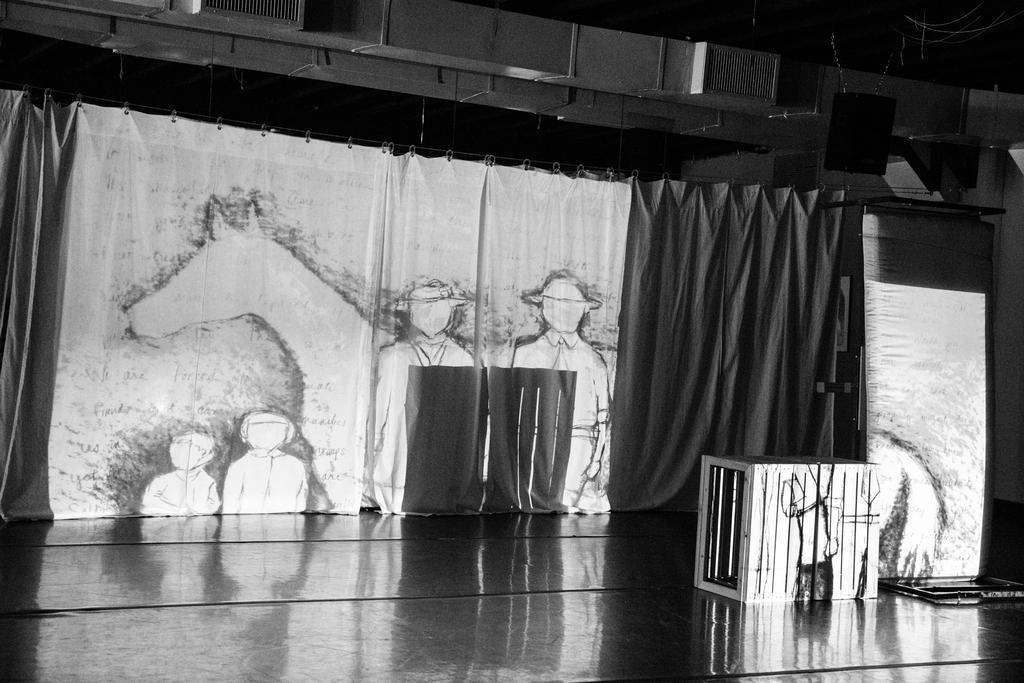Could you give a brief overview of what you see in this image? This picture seems to be clicked inside the hall. In the foreground we can see there are some objects placed on the ground. In the background we can see the curtains, some pictures on the curtain and we can see a black color object seems to be the speaker and we can see some other objects. 